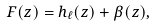<formula> <loc_0><loc_0><loc_500><loc_500>F ( z ) = h _ { \ell } ( z ) + \beta ( z ) ,</formula> 